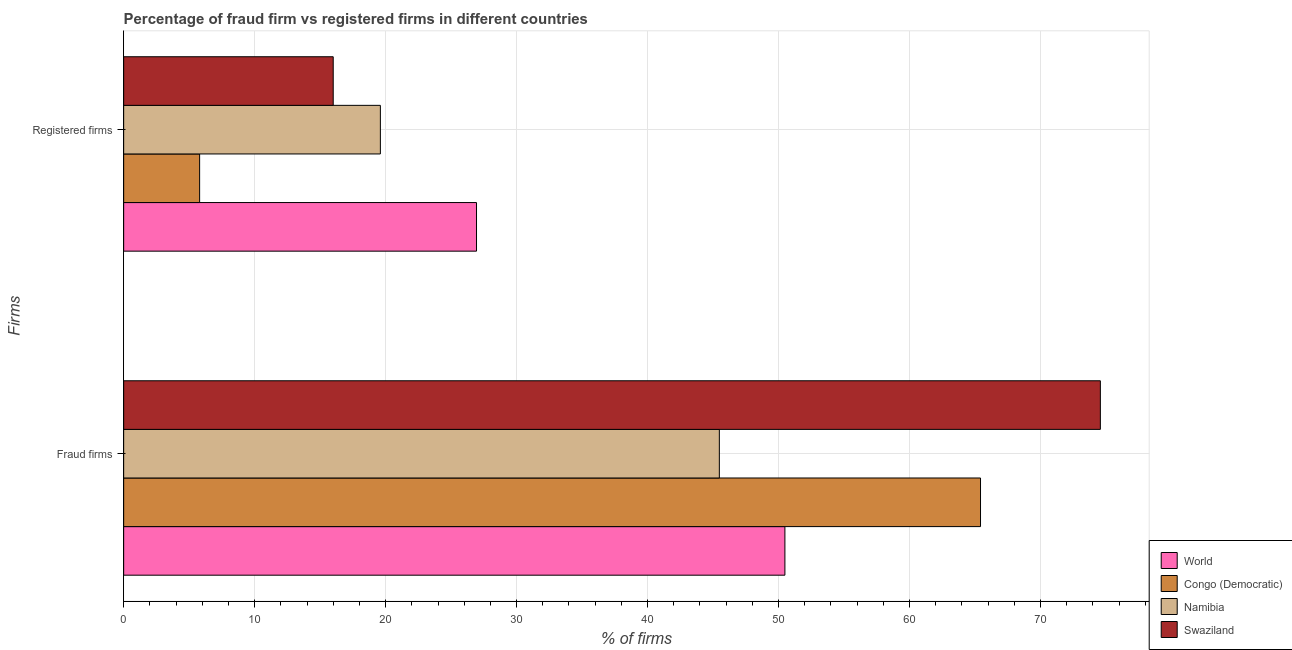How many groups of bars are there?
Your response must be concise. 2. What is the label of the 2nd group of bars from the top?
Give a very brief answer. Fraud firms. Across all countries, what is the maximum percentage of fraud firms?
Keep it short and to the point. 74.57. Across all countries, what is the minimum percentage of registered firms?
Give a very brief answer. 5.8. In which country was the percentage of fraud firms minimum?
Make the answer very short. Namibia. What is the total percentage of registered firms in the graph?
Ensure brevity in your answer.  68.34. What is the difference between the percentage of fraud firms in World and that in Congo (Democratic)?
Your answer should be compact. -14.93. What is the difference between the percentage of registered firms in Namibia and the percentage of fraud firms in World?
Your answer should be compact. -30.89. What is the average percentage of fraud firms per country?
Your answer should be compact. 58.99. What is the difference between the percentage of fraud firms and percentage of registered firms in World?
Keep it short and to the point. 23.55. In how many countries, is the percentage of registered firms greater than 42 %?
Keep it short and to the point. 0. What is the ratio of the percentage of fraud firms in World to that in Congo (Democratic)?
Provide a succinct answer. 0.77. What does the 4th bar from the bottom in Fraud firms represents?
Provide a succinct answer. Swaziland. How many bars are there?
Provide a succinct answer. 8. Are all the bars in the graph horizontal?
Make the answer very short. Yes. How many countries are there in the graph?
Your response must be concise. 4. What is the difference between two consecutive major ticks on the X-axis?
Offer a terse response. 10. Are the values on the major ticks of X-axis written in scientific E-notation?
Your answer should be very brief. No. Does the graph contain any zero values?
Keep it short and to the point. No. How many legend labels are there?
Keep it short and to the point. 4. What is the title of the graph?
Give a very brief answer. Percentage of fraud firm vs registered firms in different countries. What is the label or title of the X-axis?
Make the answer very short. % of firms. What is the label or title of the Y-axis?
Make the answer very short. Firms. What is the % of firms in World in Fraud firms?
Make the answer very short. 50.49. What is the % of firms in Congo (Democratic) in Fraud firms?
Offer a very short reply. 65.42. What is the % of firms in Namibia in Fraud firms?
Offer a very short reply. 45.48. What is the % of firms in Swaziland in Fraud firms?
Ensure brevity in your answer.  74.57. What is the % of firms of World in Registered firms?
Offer a very short reply. 26.94. What is the % of firms in Namibia in Registered firms?
Provide a succinct answer. 19.6. What is the % of firms of Swaziland in Registered firms?
Offer a terse response. 16. Across all Firms, what is the maximum % of firms of World?
Make the answer very short. 50.49. Across all Firms, what is the maximum % of firms in Congo (Democratic)?
Provide a succinct answer. 65.42. Across all Firms, what is the maximum % of firms in Namibia?
Offer a very short reply. 45.48. Across all Firms, what is the maximum % of firms in Swaziland?
Your response must be concise. 74.57. Across all Firms, what is the minimum % of firms of World?
Give a very brief answer. 26.94. Across all Firms, what is the minimum % of firms of Congo (Democratic)?
Make the answer very short. 5.8. Across all Firms, what is the minimum % of firms in Namibia?
Offer a terse response. 19.6. What is the total % of firms of World in the graph?
Offer a very short reply. 77.43. What is the total % of firms of Congo (Democratic) in the graph?
Offer a terse response. 71.22. What is the total % of firms of Namibia in the graph?
Your response must be concise. 65.08. What is the total % of firms in Swaziland in the graph?
Offer a terse response. 90.57. What is the difference between the % of firms of World in Fraud firms and that in Registered firms?
Your response must be concise. 23.55. What is the difference between the % of firms of Congo (Democratic) in Fraud firms and that in Registered firms?
Keep it short and to the point. 59.62. What is the difference between the % of firms in Namibia in Fraud firms and that in Registered firms?
Give a very brief answer. 25.88. What is the difference between the % of firms of Swaziland in Fraud firms and that in Registered firms?
Keep it short and to the point. 58.57. What is the difference between the % of firms of World in Fraud firms and the % of firms of Congo (Democratic) in Registered firms?
Make the answer very short. 44.69. What is the difference between the % of firms of World in Fraud firms and the % of firms of Namibia in Registered firms?
Provide a succinct answer. 30.89. What is the difference between the % of firms in World in Fraud firms and the % of firms in Swaziland in Registered firms?
Your response must be concise. 34.49. What is the difference between the % of firms in Congo (Democratic) in Fraud firms and the % of firms in Namibia in Registered firms?
Keep it short and to the point. 45.82. What is the difference between the % of firms in Congo (Democratic) in Fraud firms and the % of firms in Swaziland in Registered firms?
Offer a terse response. 49.42. What is the difference between the % of firms in Namibia in Fraud firms and the % of firms in Swaziland in Registered firms?
Make the answer very short. 29.48. What is the average % of firms in World per Firms?
Give a very brief answer. 38.71. What is the average % of firms of Congo (Democratic) per Firms?
Give a very brief answer. 35.61. What is the average % of firms in Namibia per Firms?
Give a very brief answer. 32.54. What is the average % of firms of Swaziland per Firms?
Ensure brevity in your answer.  45.28. What is the difference between the % of firms of World and % of firms of Congo (Democratic) in Fraud firms?
Your answer should be very brief. -14.93. What is the difference between the % of firms in World and % of firms in Namibia in Fraud firms?
Your answer should be very brief. 5.01. What is the difference between the % of firms in World and % of firms in Swaziland in Fraud firms?
Make the answer very short. -24.08. What is the difference between the % of firms of Congo (Democratic) and % of firms of Namibia in Fraud firms?
Give a very brief answer. 19.94. What is the difference between the % of firms of Congo (Democratic) and % of firms of Swaziland in Fraud firms?
Offer a very short reply. -9.15. What is the difference between the % of firms of Namibia and % of firms of Swaziland in Fraud firms?
Provide a short and direct response. -29.09. What is the difference between the % of firms in World and % of firms in Congo (Democratic) in Registered firms?
Provide a short and direct response. 21.14. What is the difference between the % of firms of World and % of firms of Namibia in Registered firms?
Keep it short and to the point. 7.34. What is the difference between the % of firms in World and % of firms in Swaziland in Registered firms?
Your answer should be compact. 10.94. What is the ratio of the % of firms in World in Fraud firms to that in Registered firms?
Ensure brevity in your answer.  1.87. What is the ratio of the % of firms in Congo (Democratic) in Fraud firms to that in Registered firms?
Provide a short and direct response. 11.28. What is the ratio of the % of firms in Namibia in Fraud firms to that in Registered firms?
Provide a short and direct response. 2.32. What is the ratio of the % of firms of Swaziland in Fraud firms to that in Registered firms?
Keep it short and to the point. 4.66. What is the difference between the highest and the second highest % of firms in World?
Make the answer very short. 23.55. What is the difference between the highest and the second highest % of firms in Congo (Democratic)?
Your answer should be very brief. 59.62. What is the difference between the highest and the second highest % of firms in Namibia?
Ensure brevity in your answer.  25.88. What is the difference between the highest and the second highest % of firms of Swaziland?
Offer a terse response. 58.57. What is the difference between the highest and the lowest % of firms of World?
Make the answer very short. 23.55. What is the difference between the highest and the lowest % of firms in Congo (Democratic)?
Provide a short and direct response. 59.62. What is the difference between the highest and the lowest % of firms in Namibia?
Your answer should be compact. 25.88. What is the difference between the highest and the lowest % of firms of Swaziland?
Your response must be concise. 58.57. 